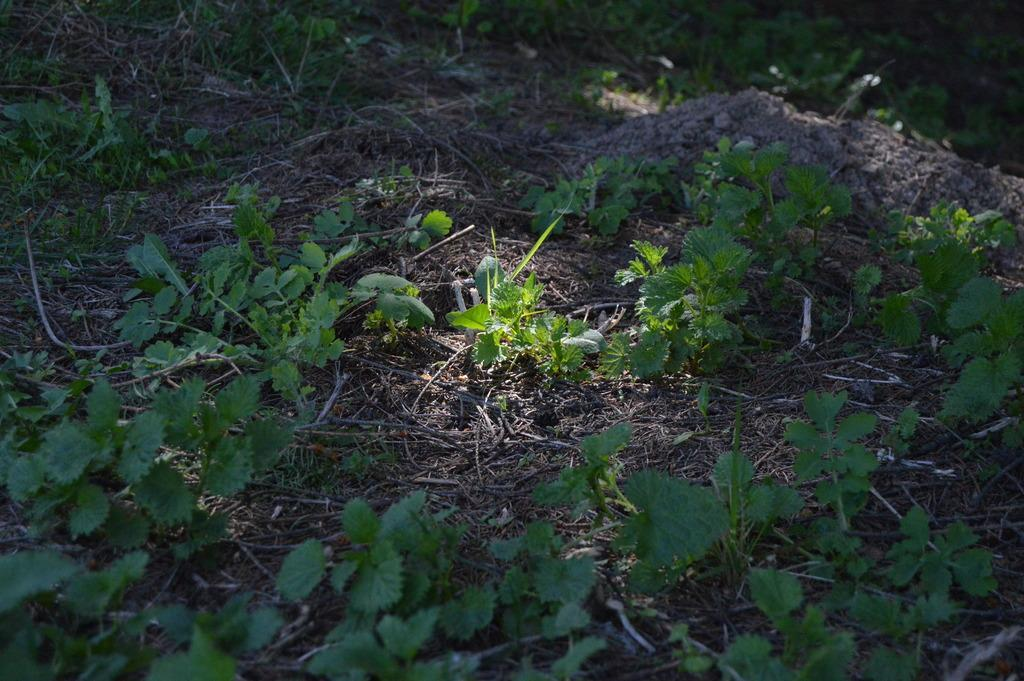What type of vegetation can be seen in the image? There are leaves in the image. What is the color of the leaves? The leaves are green in color. How many cats can be seen playing with the stem of the door in the image? There are no cats, stems, or doors present in the image; it only features leaves. 